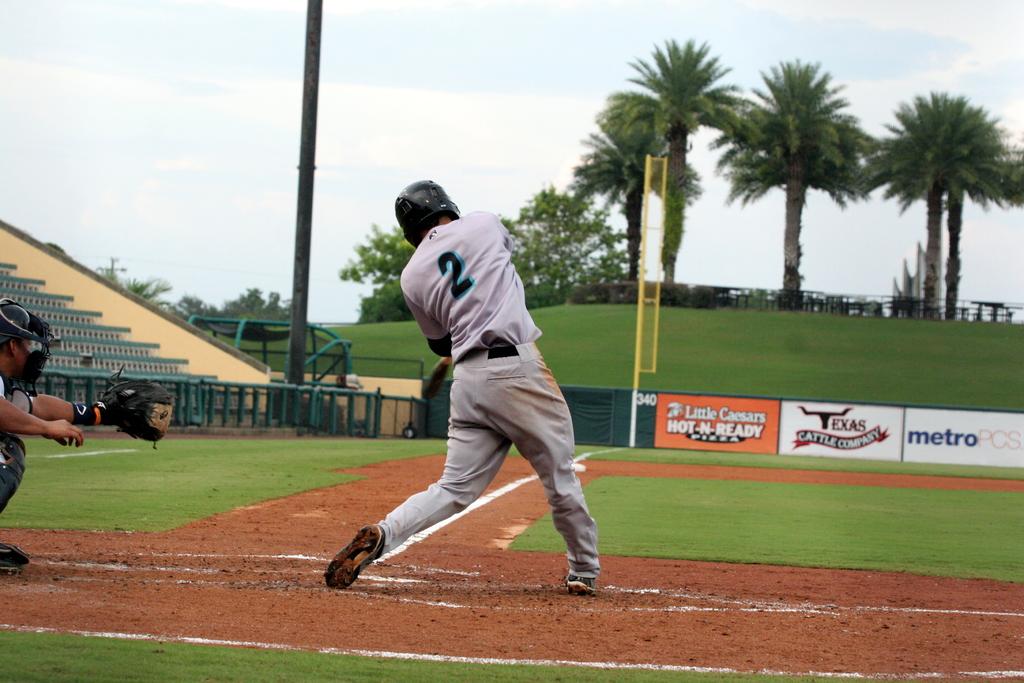Who has "hot - n - ready pizza?"?
Make the answer very short. Little caesars. 